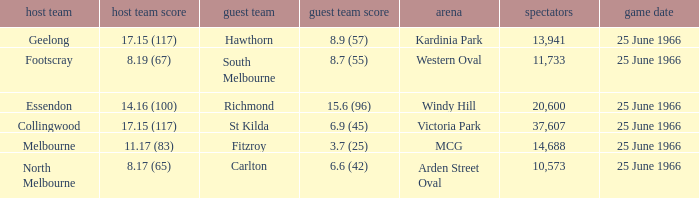What is the total crowd size when a home team scored 17.15 (117) versus hawthorn? 13941.0. 